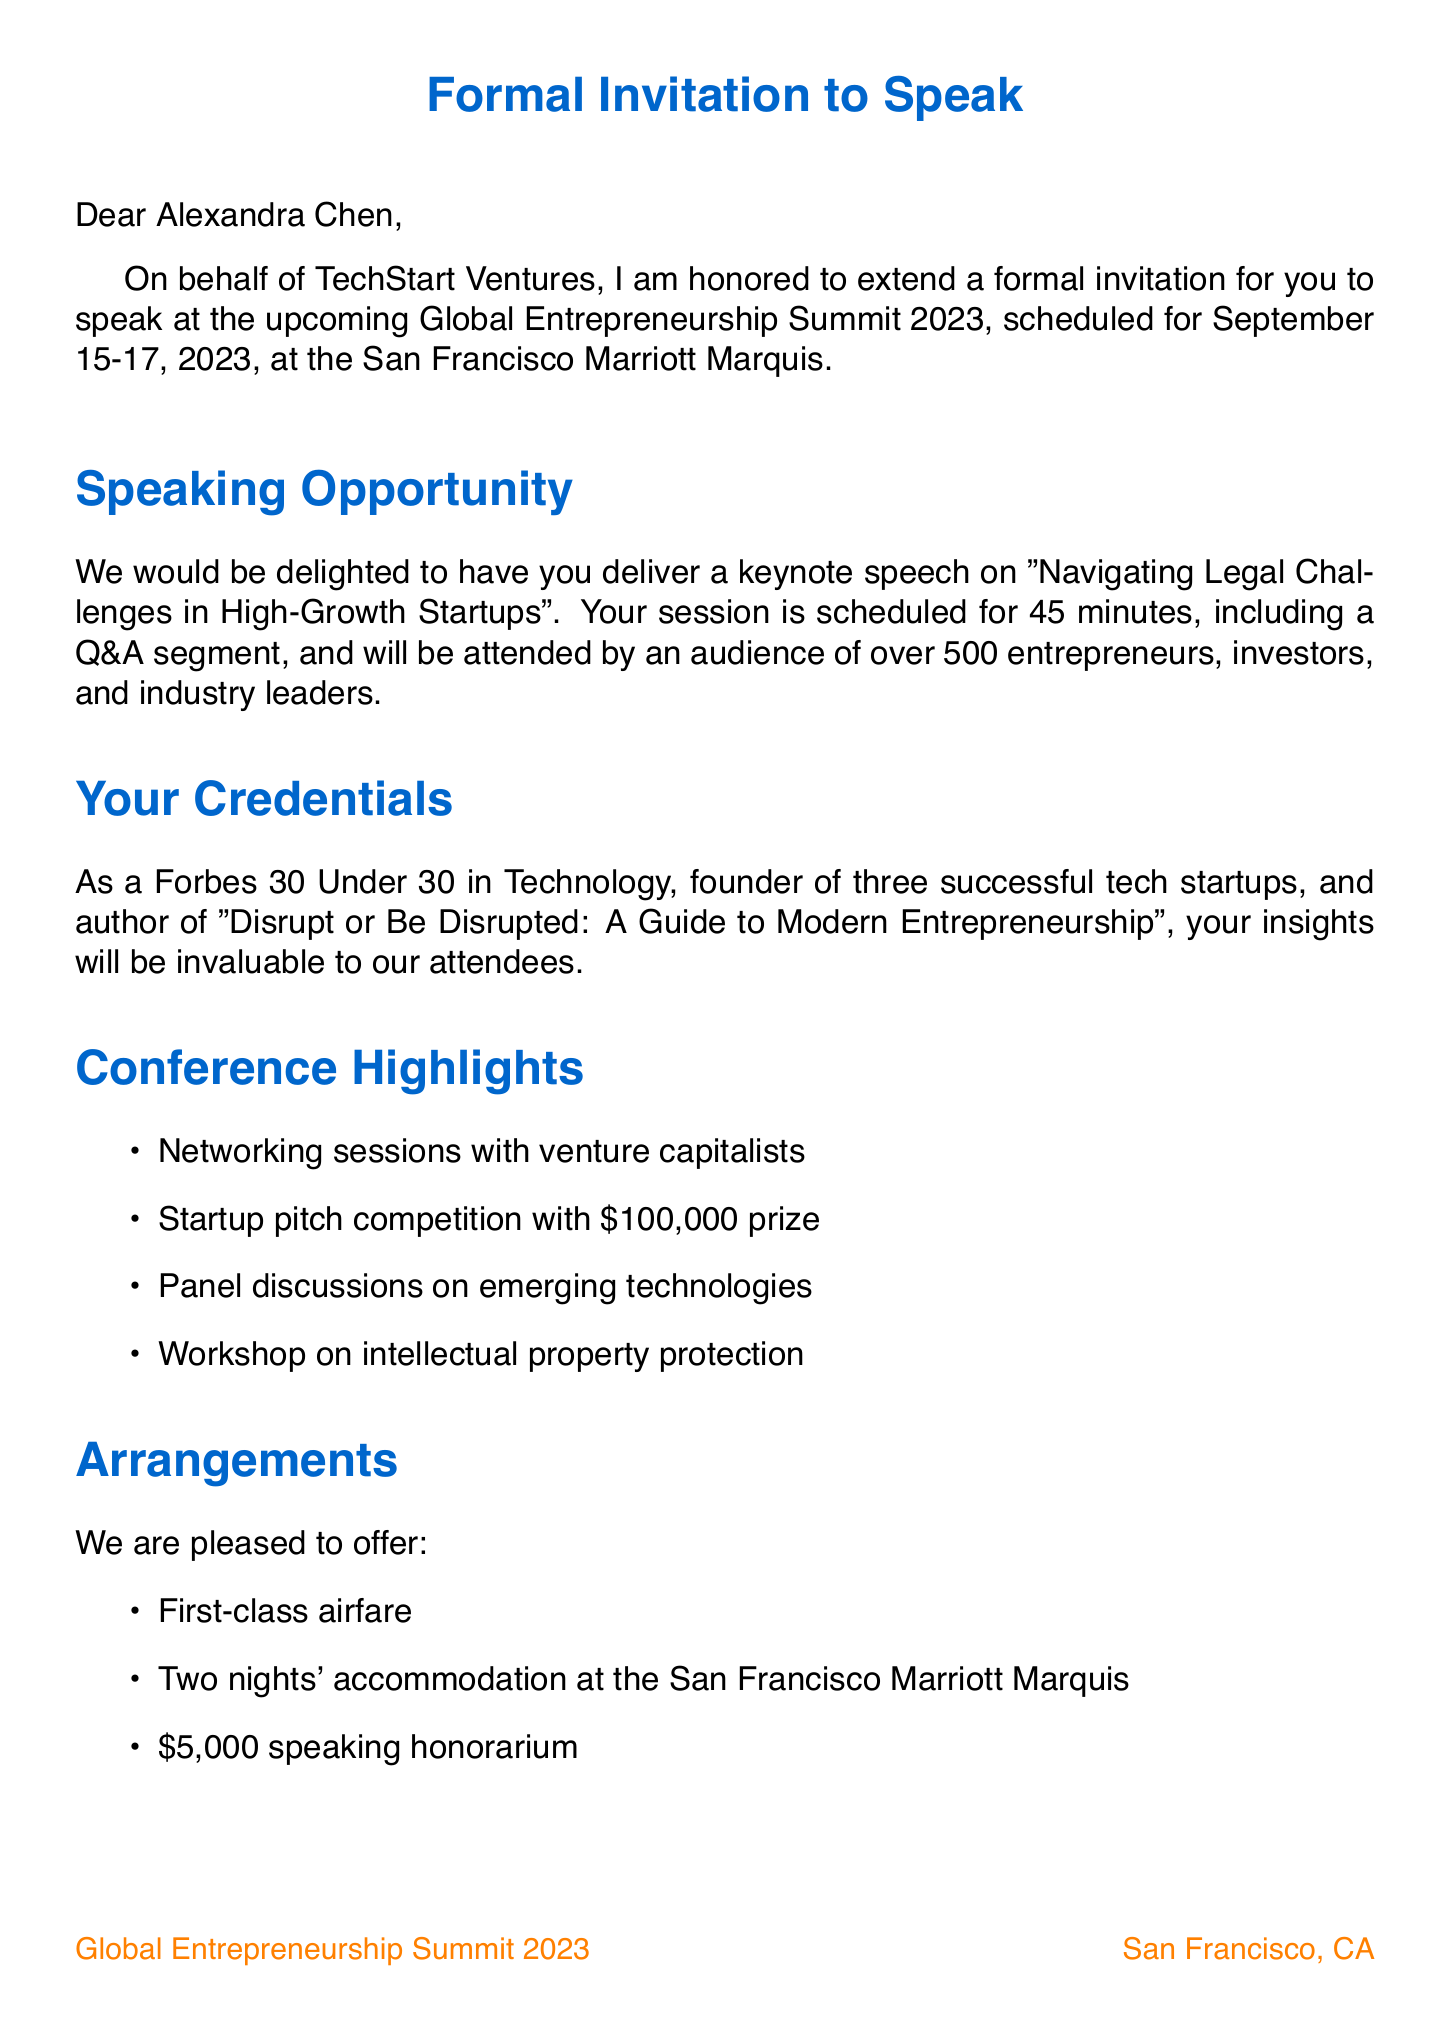What is the conference name? The conference name is explicitly mentioned in the document as the title of the event.
Answer: Global Entrepreneurship Summit 2023 What are the dates of the conference? The dates are listed in the event details section of the document.
Answer: September 15-17, 2023 Who is the organizer of the conference? The organizer is specified in the event details section of the letter.
Answer: TechStart Ventures What is the expected audience size? This information is provided within the speaking opportunity section, illustrating the potential reach of the event.
Answer: 500+ What is the speaking fee? The honorarium is clearly stated under the logistical details section of the document.
Answer: $5,000 What is the title of the keynote speech? The session title is mentioned directly in the speaking opportunity section of the document.
Answer: Navigating Legal Challenges in High-Growth Startups Who should be contacted for further information? The document specifies an event coordinator for inquiries about the event.
Answer: Sarah Thompson What materials are requested from the speaker? The materials needed are listed point-by-point as part of the request details.
Answer: High-resolution headshot, Short bio, Session outline, Any technical requirements What additional opportunity is available at the conference? The document highlights several additional opportunities available to the speaker.
Answer: VIP dinner with conference sponsors 